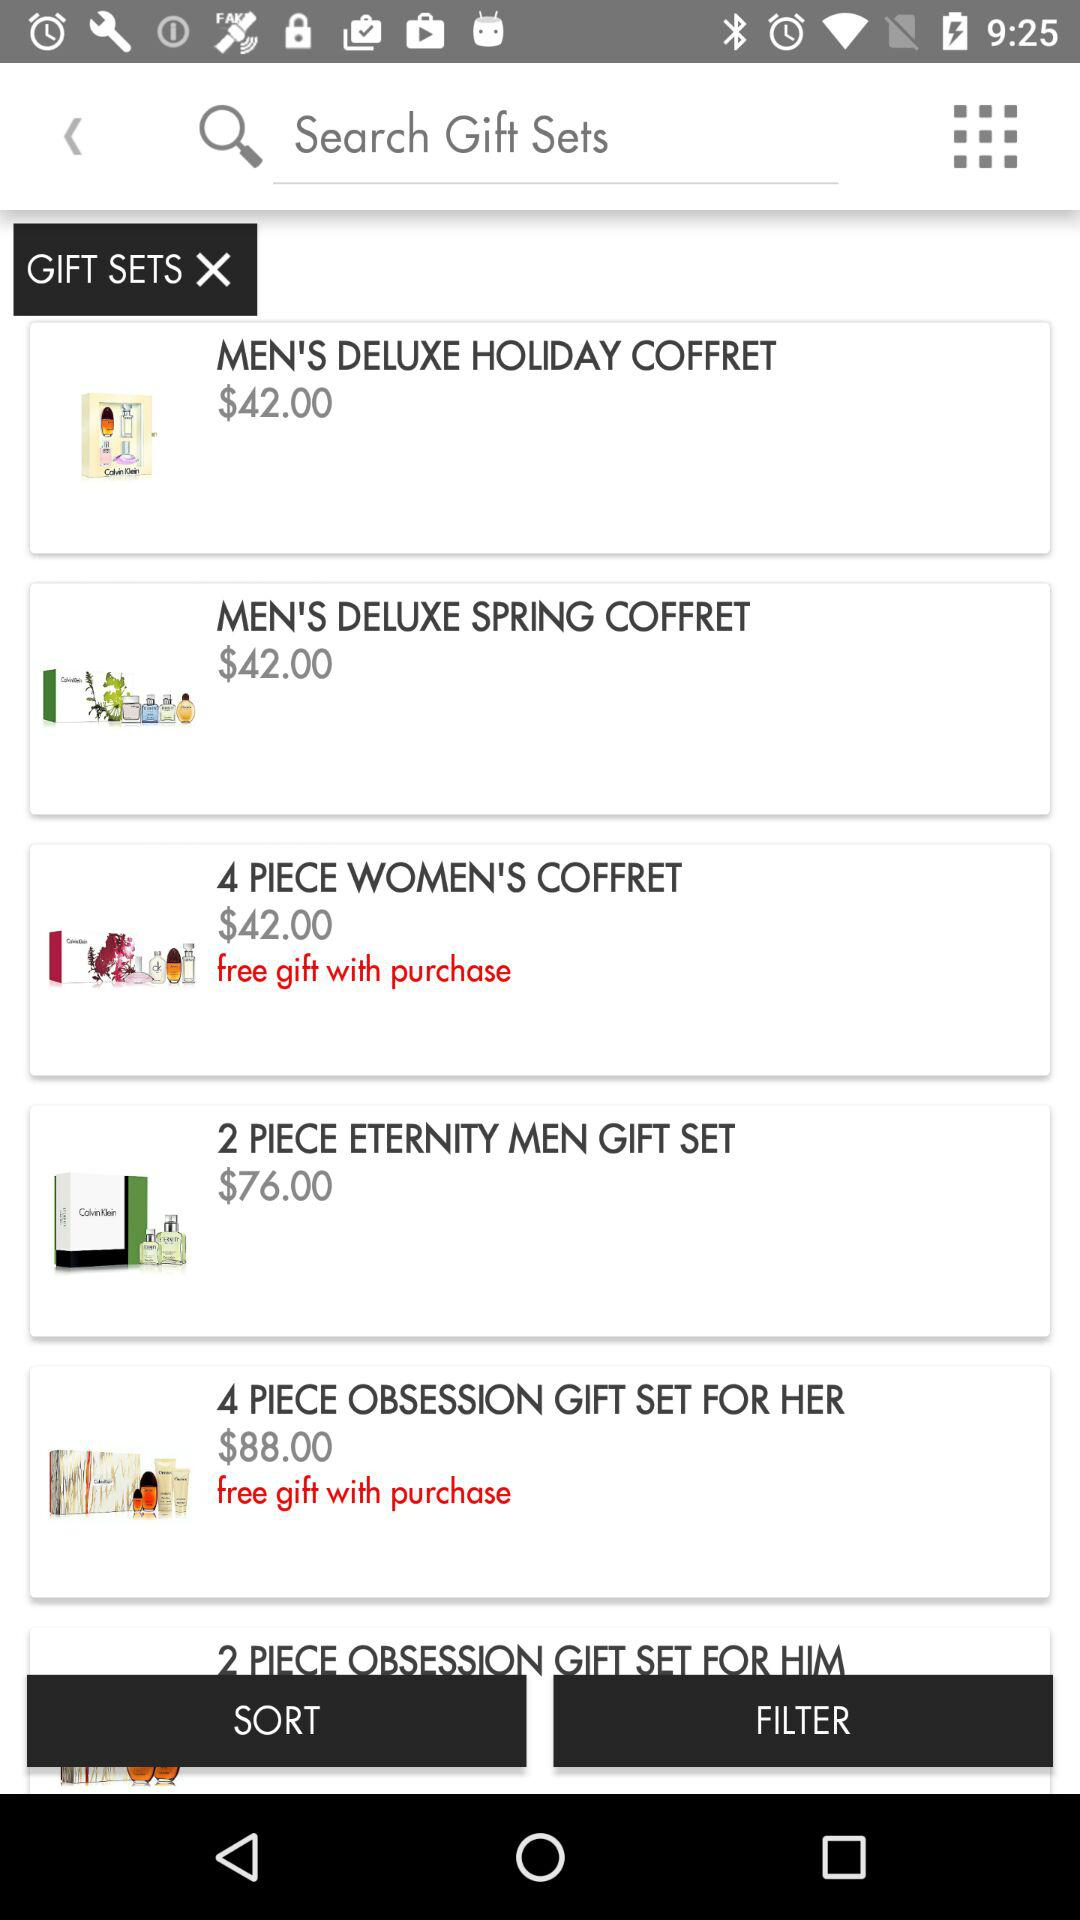How many gift sets have a price of more than $42.00?
Answer the question using a single word or phrase. 2 